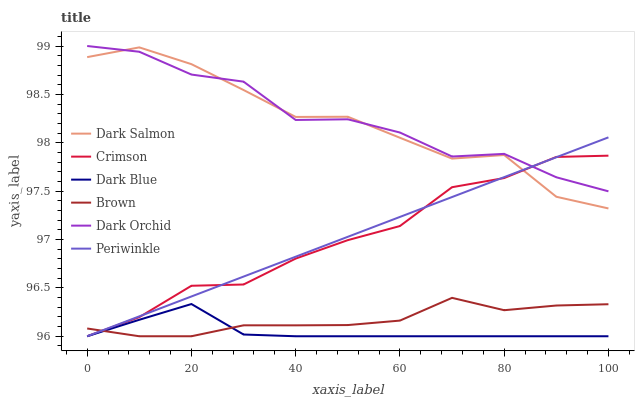Does Dark Blue have the minimum area under the curve?
Answer yes or no. Yes. Does Dark Orchid have the maximum area under the curve?
Answer yes or no. Yes. Does Dark Salmon have the minimum area under the curve?
Answer yes or no. No. Does Dark Salmon have the maximum area under the curve?
Answer yes or no. No. Is Periwinkle the smoothest?
Answer yes or no. Yes. Is Dark Orchid the roughest?
Answer yes or no. Yes. Is Dark Salmon the smoothest?
Answer yes or no. No. Is Dark Salmon the roughest?
Answer yes or no. No. Does Brown have the lowest value?
Answer yes or no. Yes. Does Dark Salmon have the lowest value?
Answer yes or no. No. Does Dark Orchid have the highest value?
Answer yes or no. Yes. Does Dark Salmon have the highest value?
Answer yes or no. No. Is Dark Blue less than Dark Salmon?
Answer yes or no. Yes. Is Dark Salmon greater than Brown?
Answer yes or no. Yes. Does Periwinkle intersect Dark Salmon?
Answer yes or no. Yes. Is Periwinkle less than Dark Salmon?
Answer yes or no. No. Is Periwinkle greater than Dark Salmon?
Answer yes or no. No. Does Dark Blue intersect Dark Salmon?
Answer yes or no. No. 